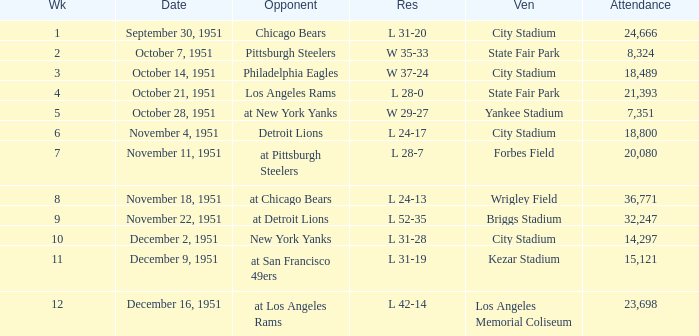Which date's week was more than 4 with the venue being City Stadium and where the attendance was more than 14,297? November 4, 1951. 